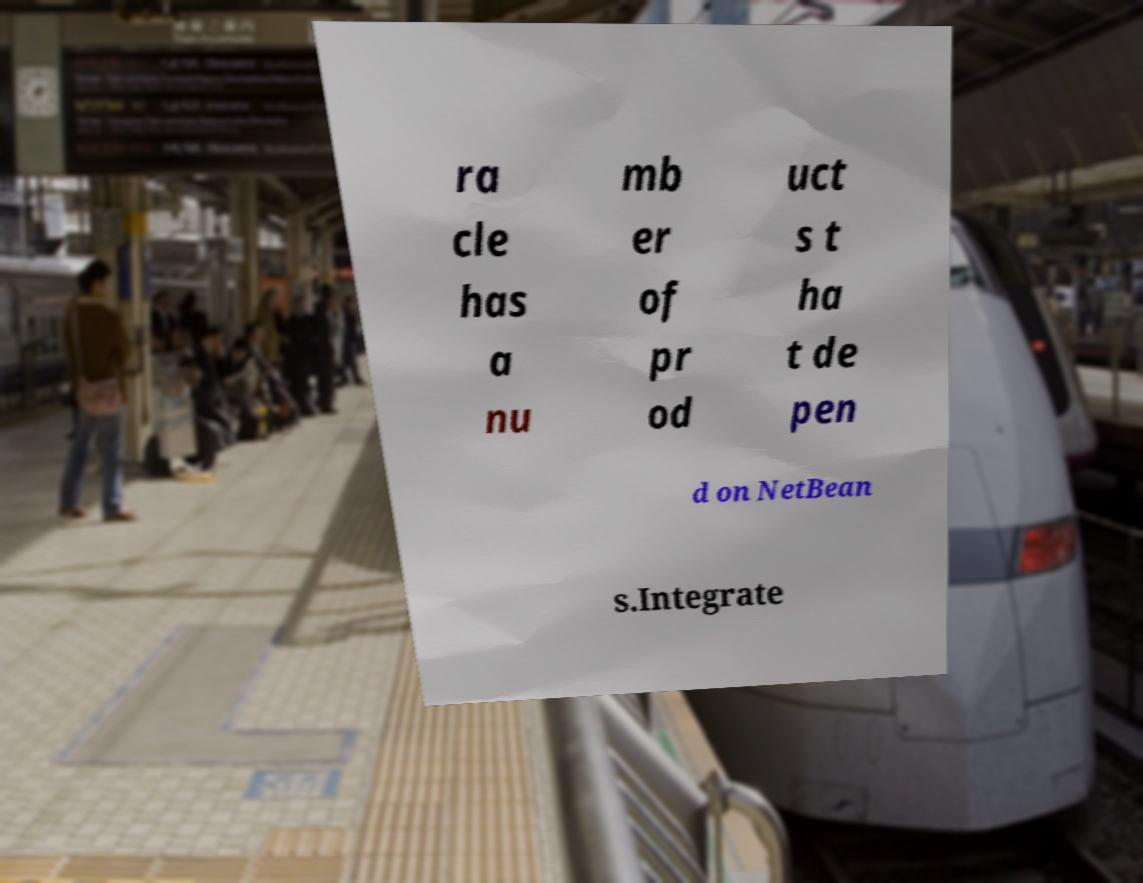Can you accurately transcribe the text from the provided image for me? ra cle has a nu mb er of pr od uct s t ha t de pen d on NetBean s.Integrate 